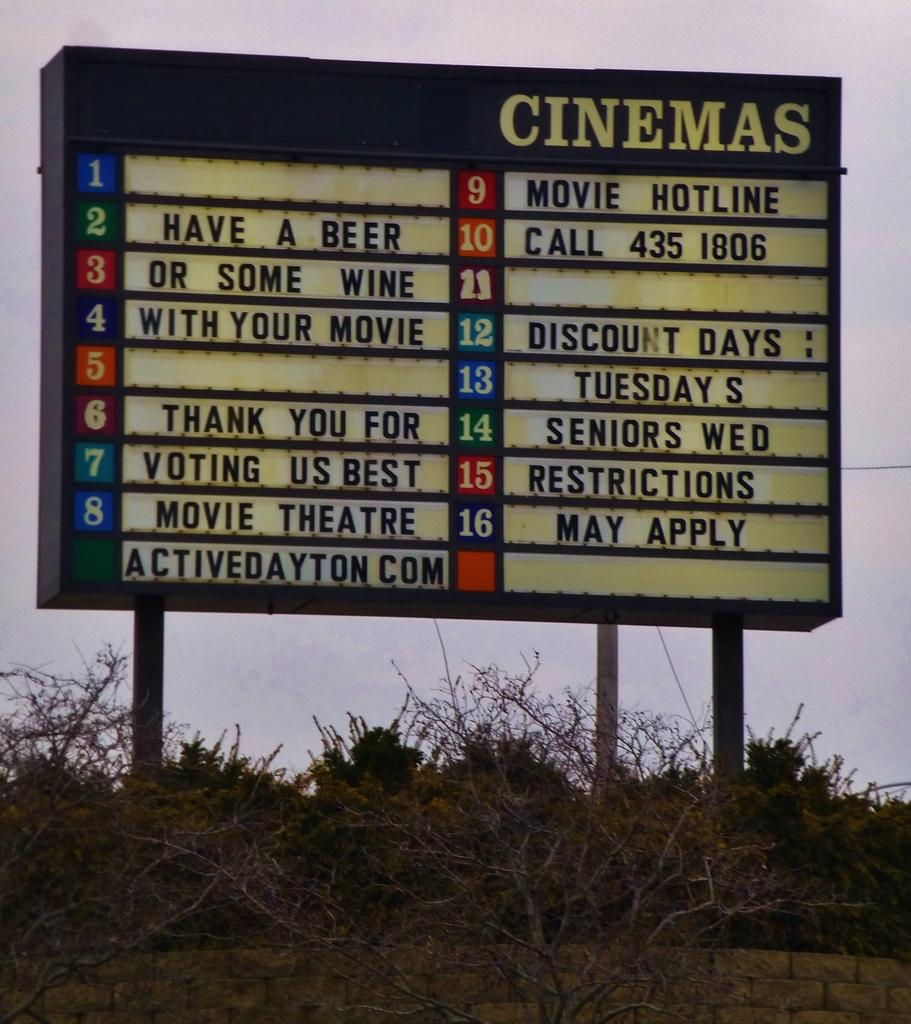<image>
Describe the image concisely. A signboard that say Cinemas at top and the number 2 feature is Have A Beer. 